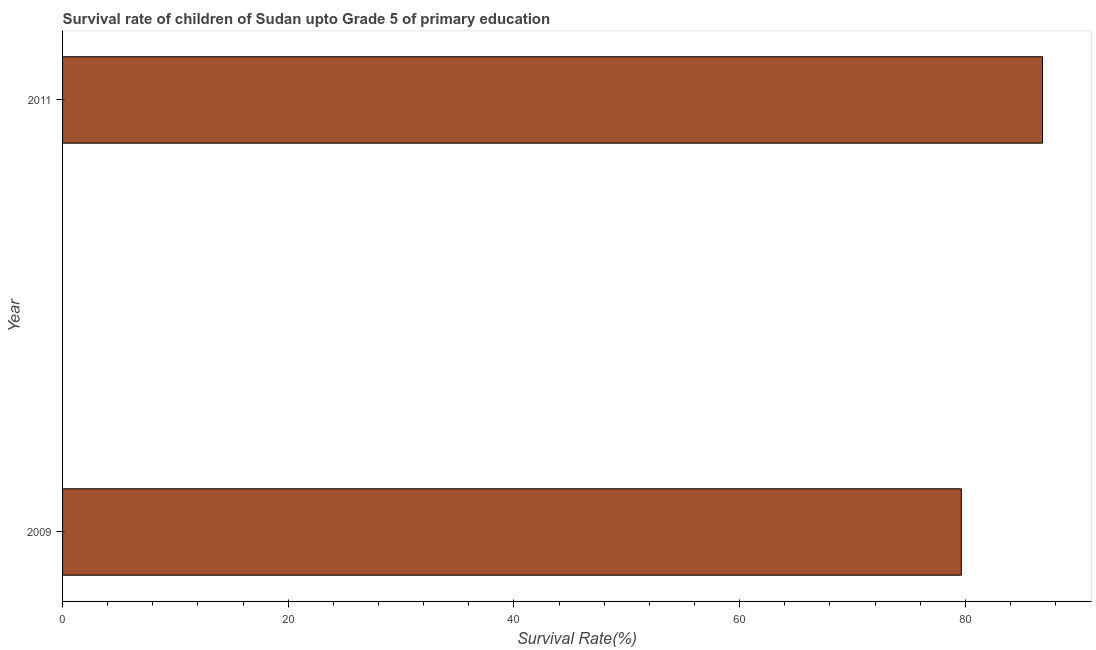What is the title of the graph?
Ensure brevity in your answer.  Survival rate of children of Sudan upto Grade 5 of primary education. What is the label or title of the X-axis?
Offer a terse response. Survival Rate(%). What is the label or title of the Y-axis?
Give a very brief answer. Year. What is the survival rate in 2009?
Keep it short and to the point. 79.65. Across all years, what is the maximum survival rate?
Your answer should be very brief. 86.84. Across all years, what is the minimum survival rate?
Provide a succinct answer. 79.65. In which year was the survival rate maximum?
Make the answer very short. 2011. In which year was the survival rate minimum?
Make the answer very short. 2009. What is the sum of the survival rate?
Your answer should be compact. 166.5. What is the difference between the survival rate in 2009 and 2011?
Provide a succinct answer. -7.19. What is the average survival rate per year?
Give a very brief answer. 83.25. What is the median survival rate?
Ensure brevity in your answer.  83.25. Do a majority of the years between 2009 and 2011 (inclusive) have survival rate greater than 48 %?
Your answer should be very brief. Yes. What is the ratio of the survival rate in 2009 to that in 2011?
Your response must be concise. 0.92. What is the difference between two consecutive major ticks on the X-axis?
Your answer should be very brief. 20. Are the values on the major ticks of X-axis written in scientific E-notation?
Provide a short and direct response. No. What is the Survival Rate(%) in 2009?
Offer a terse response. 79.65. What is the Survival Rate(%) of 2011?
Keep it short and to the point. 86.84. What is the difference between the Survival Rate(%) in 2009 and 2011?
Provide a succinct answer. -7.19. What is the ratio of the Survival Rate(%) in 2009 to that in 2011?
Ensure brevity in your answer.  0.92. 